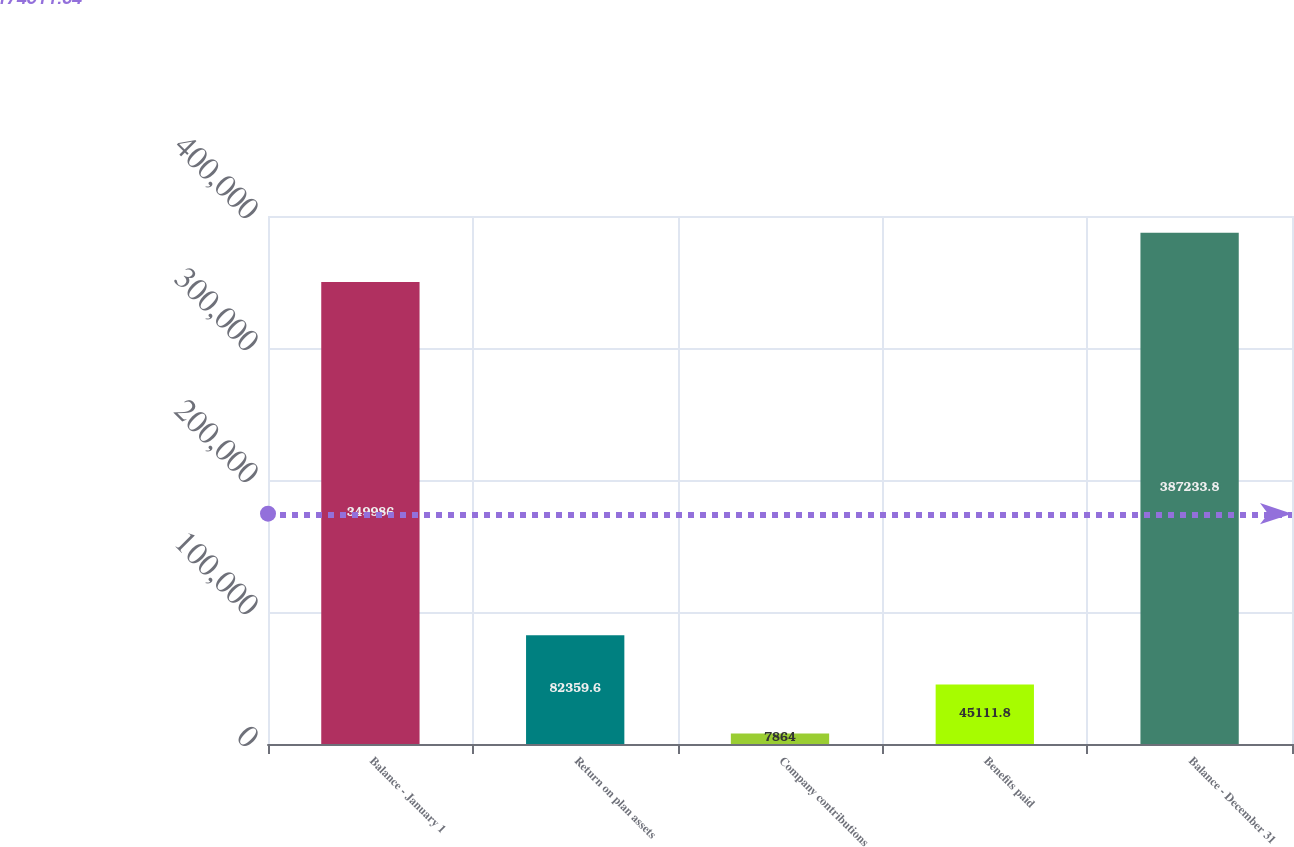<chart> <loc_0><loc_0><loc_500><loc_500><bar_chart><fcel>Balance - January 1<fcel>Return on plan assets<fcel>Company contributions<fcel>Benefits paid<fcel>Balance - December 31<nl><fcel>349986<fcel>82359.6<fcel>7864<fcel>45111.8<fcel>387234<nl></chart> 